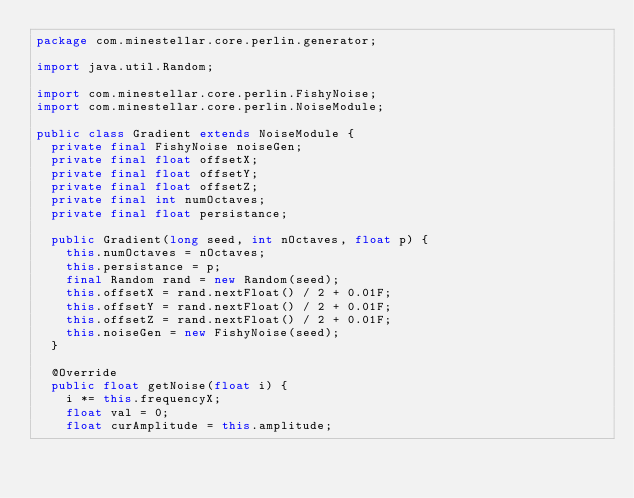<code> <loc_0><loc_0><loc_500><loc_500><_Java_>package com.minestellar.core.perlin.generator;

import java.util.Random;

import com.minestellar.core.perlin.FishyNoise;
import com.minestellar.core.perlin.NoiseModule;

public class Gradient extends NoiseModule {
	private final FishyNoise noiseGen;
	private final float offsetX;
	private final float offsetY;
	private final float offsetZ;
	private final int numOctaves;
	private final float persistance;

	public Gradient(long seed, int nOctaves, float p) {
		this.numOctaves = nOctaves;
		this.persistance = p;
		final Random rand = new Random(seed);
		this.offsetX = rand.nextFloat() / 2 + 0.01F;
		this.offsetY = rand.nextFloat() / 2 + 0.01F;
		this.offsetZ = rand.nextFloat() / 2 + 0.01F;
		this.noiseGen = new FishyNoise(seed);
	}

	@Override
	public float getNoise(float i) {
		i *= this.frequencyX;
		float val = 0;
		float curAmplitude = this.amplitude;
		</code> 